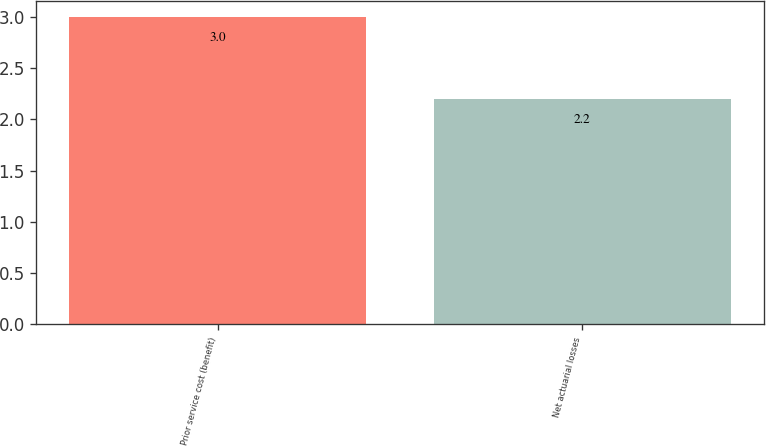Convert chart to OTSL. <chart><loc_0><loc_0><loc_500><loc_500><bar_chart><fcel>Prior service cost (benefit)<fcel>Net actuarial losses<nl><fcel>3<fcel>2.2<nl></chart> 